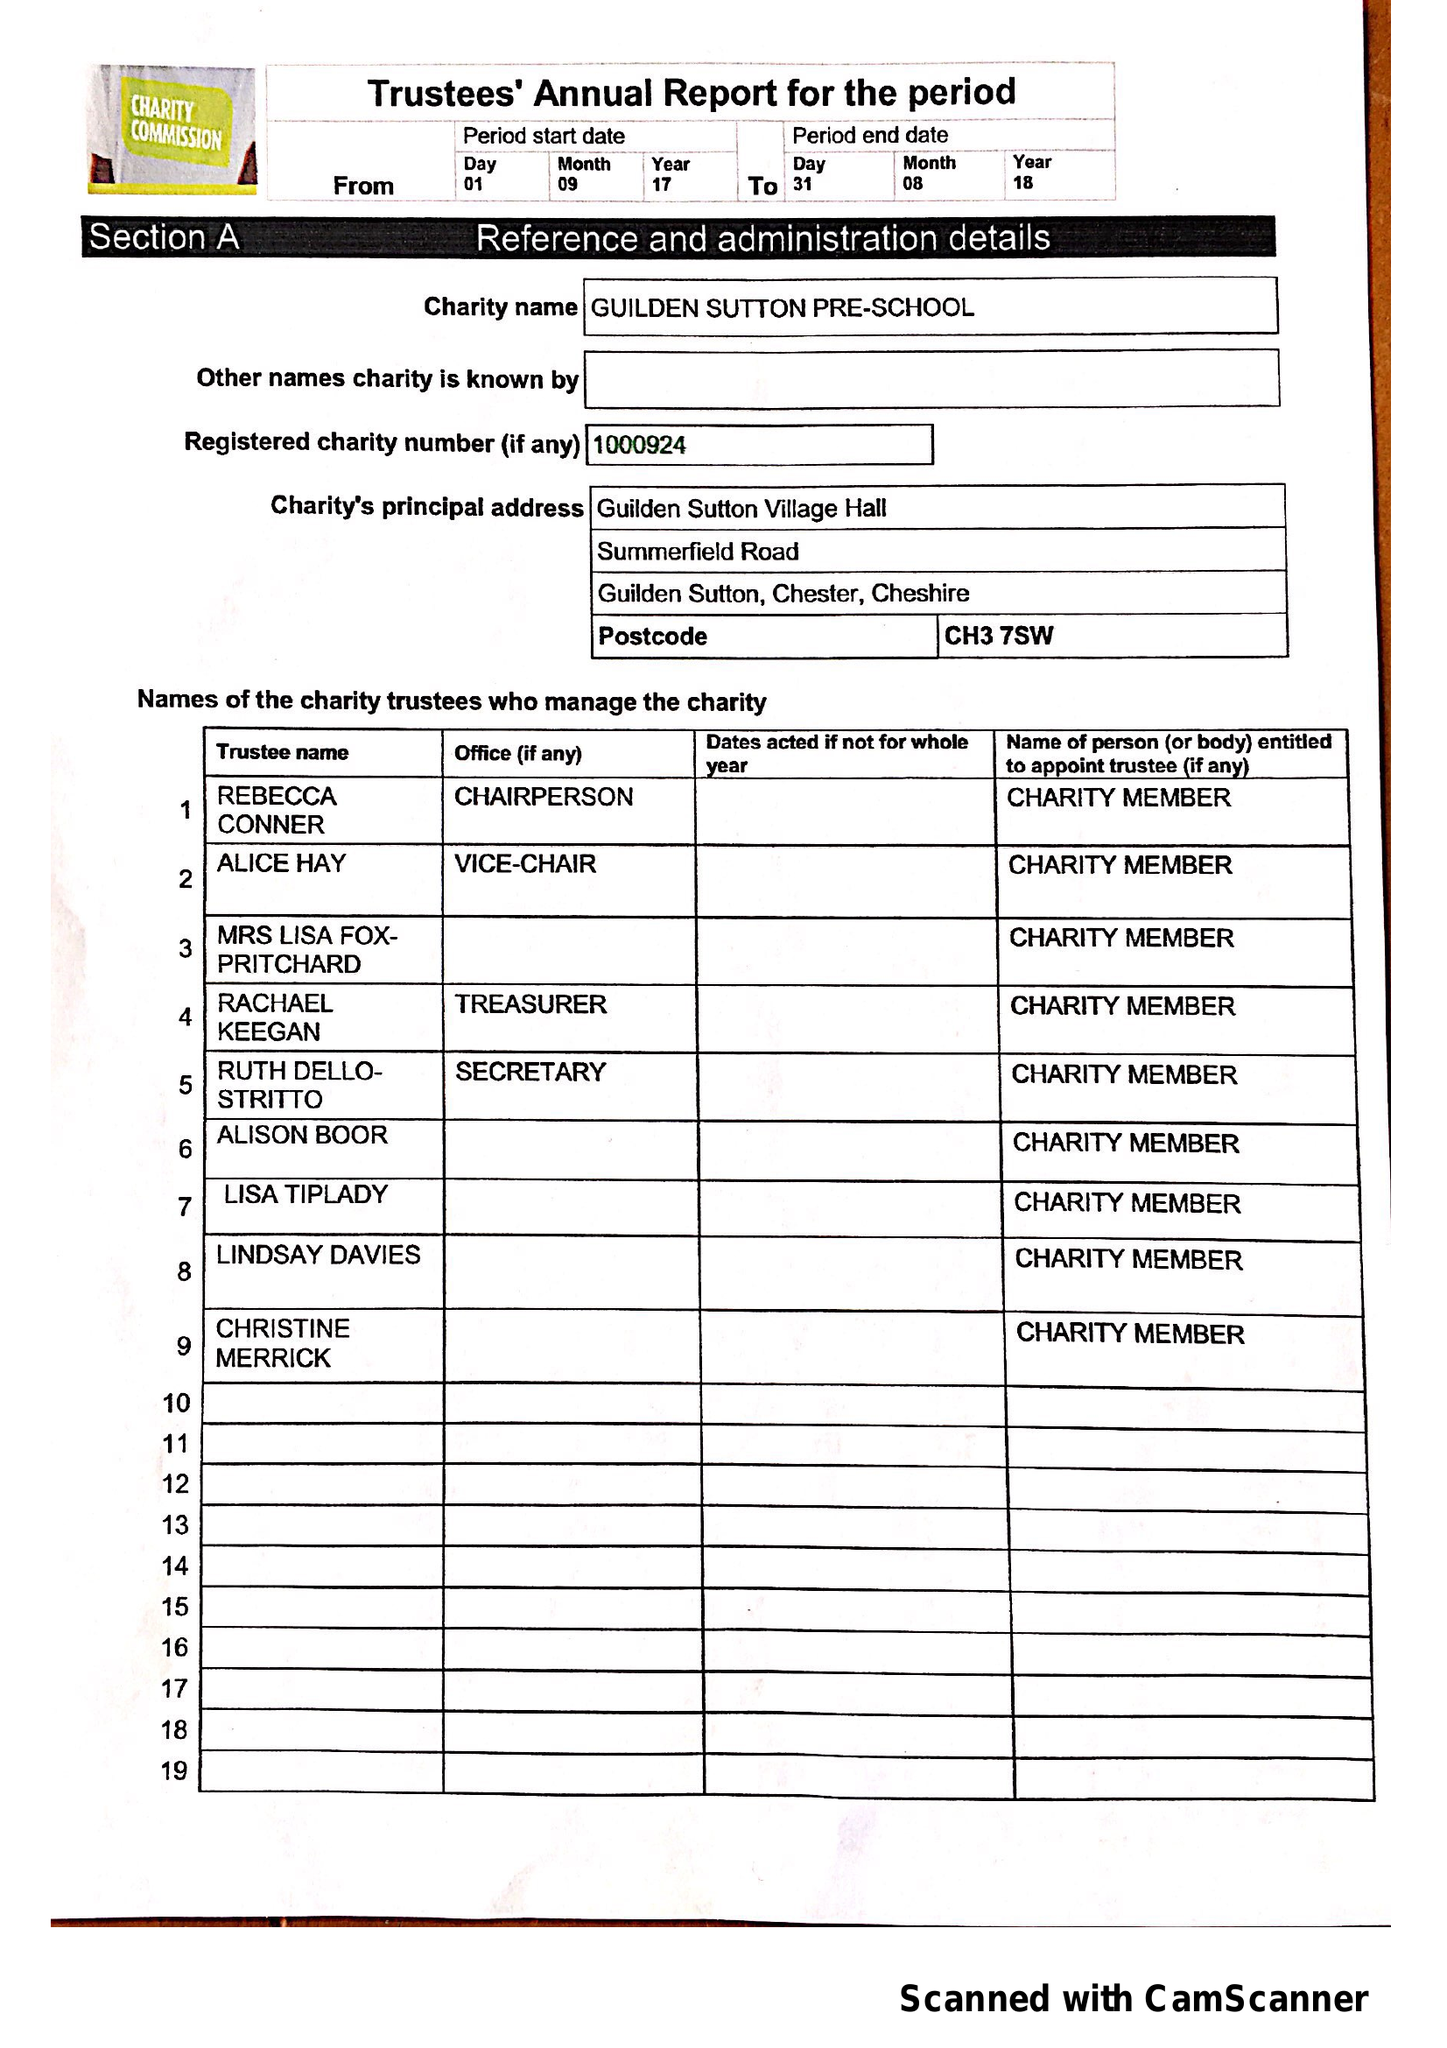What is the value for the address__post_town?
Answer the question using a single word or phrase. CHESTER 